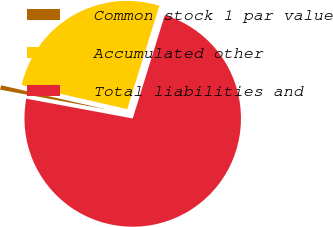<chart> <loc_0><loc_0><loc_500><loc_500><pie_chart><fcel>Common stock 1 par value<fcel>Accumulated other<fcel>Total liabilities and<nl><fcel>0.66%<fcel>26.21%<fcel>73.13%<nl></chart> 